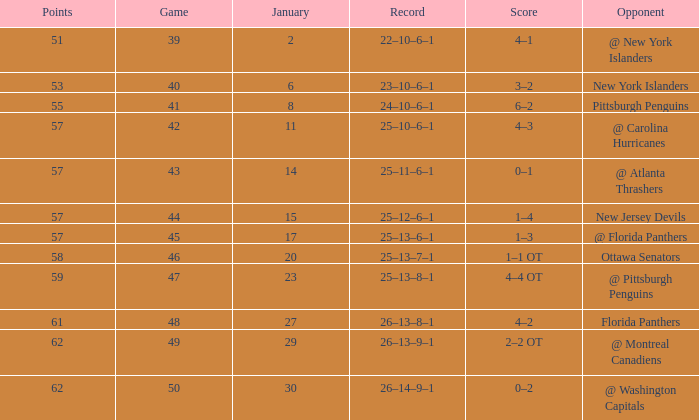Can you parse all the data within this table? {'header': ['Points', 'Game', 'January', 'Record', 'Score', 'Opponent'], 'rows': [['51', '39', '2', '22–10–6–1', '4–1', '@ New York Islanders'], ['53', '40', '6', '23–10–6–1', '3–2', 'New York Islanders'], ['55', '41', '8', '24–10–6–1', '6–2', 'Pittsburgh Penguins'], ['57', '42', '11', '25–10–6–1', '4–3', '@ Carolina Hurricanes'], ['57', '43', '14', '25–11–6–1', '0–1', '@ Atlanta Thrashers'], ['57', '44', '15', '25–12–6–1', '1–4', 'New Jersey Devils'], ['57', '45', '17', '25–13–6–1', '1–3', '@ Florida Panthers'], ['58', '46', '20', '25–13–7–1', '1–1 OT', 'Ottawa Senators'], ['59', '47', '23', '25–13–8–1', '4–4 OT', '@ Pittsburgh Penguins'], ['61', '48', '27', '26–13–8–1', '4–2', 'Florida Panthers'], ['62', '49', '29', '26–13–9–1', '2–2 OT', '@ Montreal Canadiens'], ['62', '50', '30', '26–14–9–1', '0–2', '@ Washington Capitals']]} What opponent has an average less than 62 and a january average less than 6 @ New York Islanders. 